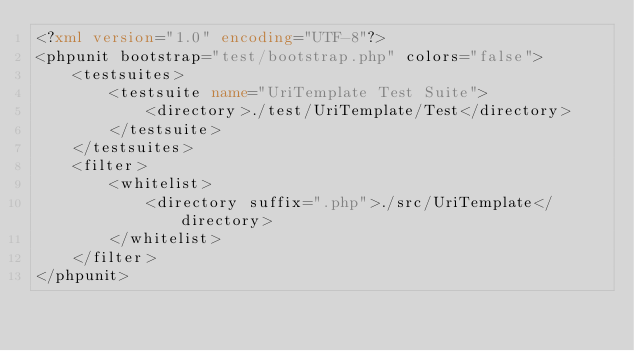Convert code to text. <code><loc_0><loc_0><loc_500><loc_500><_XML_><?xml version="1.0" encoding="UTF-8"?>
<phpunit bootstrap="test/bootstrap.php" colors="false">
    <testsuites>
        <testsuite name="UriTemplate Test Suite">
            <directory>./test/UriTemplate/Test</directory>
        </testsuite>
    </testsuites>
    <filter>
        <whitelist>
            <directory suffix=".php">./src/UriTemplate</directory>
        </whitelist>
    </filter>
</phpunit>
</code> 